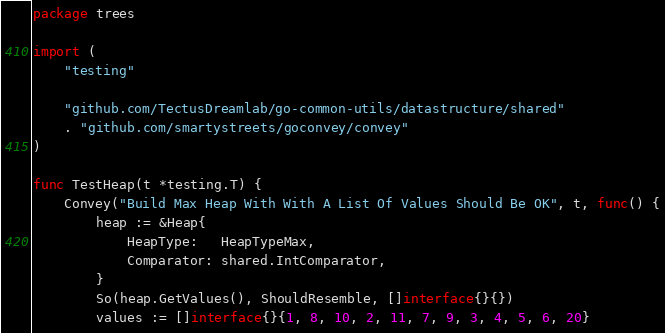Convert code to text. <code><loc_0><loc_0><loc_500><loc_500><_Go_>package trees

import (
	"testing"

	"github.com/TectusDreamlab/go-common-utils/datastructure/shared"
	. "github.com/smartystreets/goconvey/convey"
)

func TestHeap(t *testing.T) {
	Convey("Build Max Heap With With A List Of Values Should Be OK", t, func() {
		heap := &Heap{
			HeapType:   HeapTypeMax,
			Comparator: shared.IntComparator,
		}
		So(heap.GetValues(), ShouldResemble, []interface{}{})
		values := []interface{}{1, 8, 10, 2, 11, 7, 9, 3, 4, 5, 6, 20}</code> 